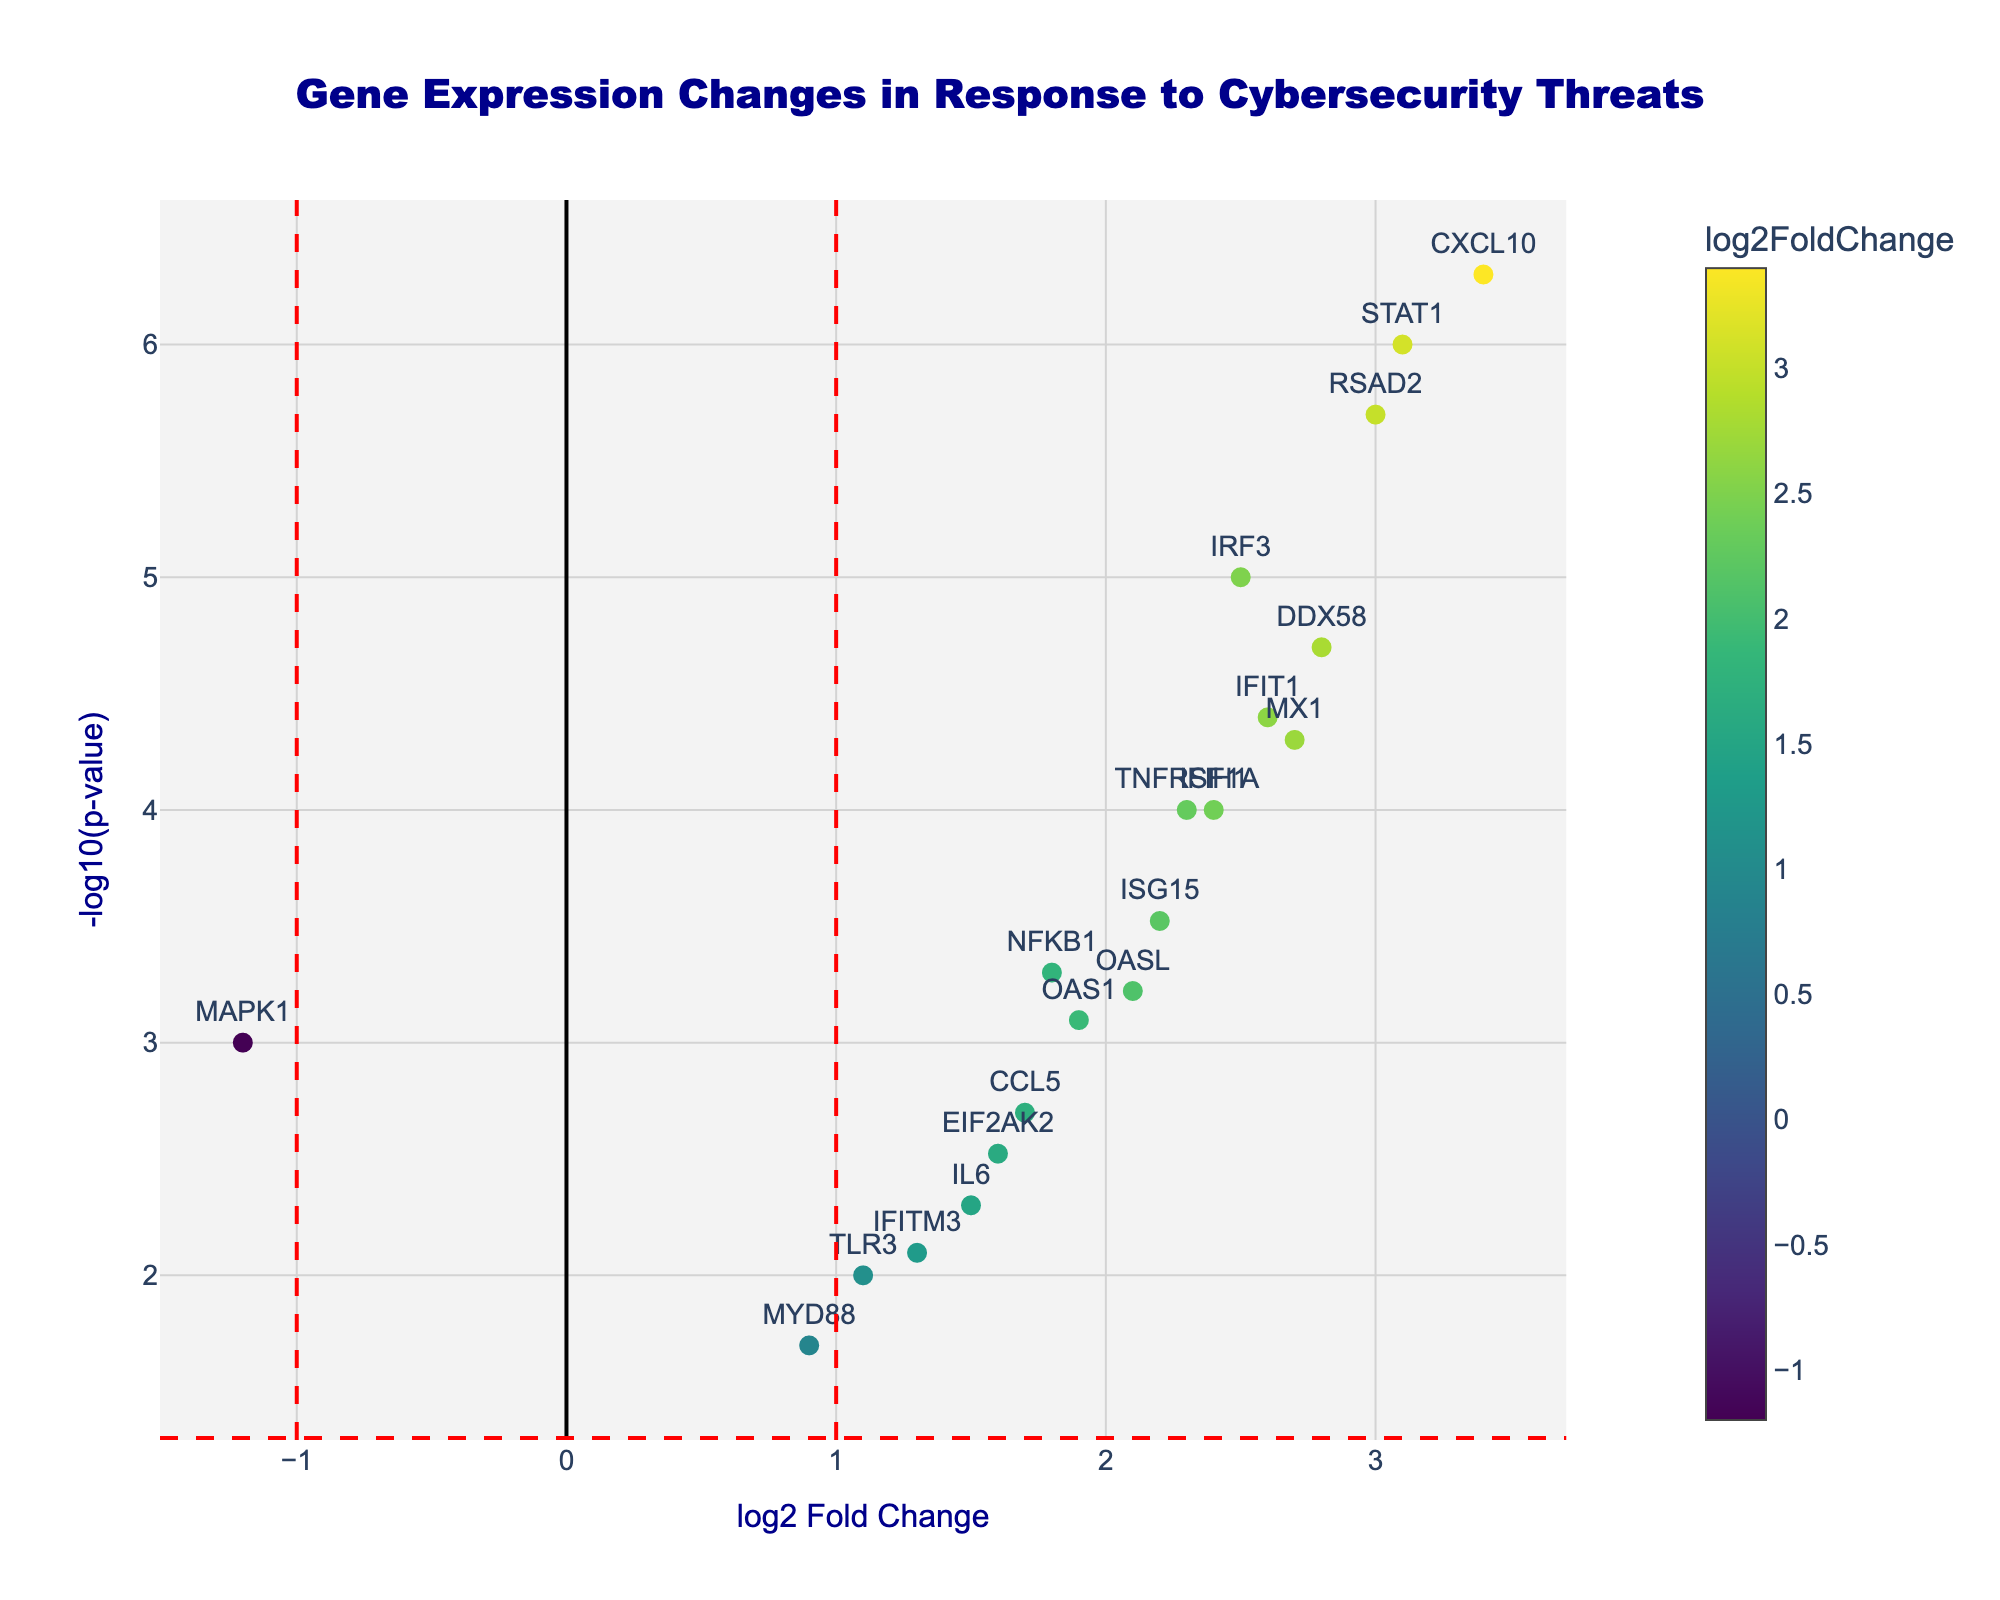What's the title of this plot? The title is clearly displayed at the top of the figure in a large, dark blue font.
Answer: Gene Expression Changes in Response to Cybersecurity Threats What are the axes labels? The x-axis is labeled "log2 Fold Change" and the y-axis is labeled "-log10(p-value)".
Answer: log2 Fold Change and -log10(p-value) How many genes have a log2 Fold Change greater than 2? By examining the x-axis, find the points to the right of the line at x = 2. These points are: TNFRSF1A, IRF3, STAT1, MX1, CXCL10, DDX58, IFIH1, IFIT1, RSAD2, and OASL.
Answer: 10 Which gene has the highest -log10(p-value)? Locate the highest point on the y-axis and identify the corresponding gene text label. The gene at the highest point is CXCL10.
Answer: CXCL10 Are there any genes with a log2 Fold Change less than -1? Check for data points to the left of the line at x = -1. There is only one such point: MAPK1.
Answer: Yes, MAPK1 What's the log2 Fold Change and p-value of the gene CXCL10? The hover text provides detailed info: "CXCL10<br>log2FC: 3.40<br>p-value: 5.00e-07".
Answer: log2FC: 3.40, p-value: 5.00e-07 Which gene has the lowest log2 Fold Change? Examine all the points and find the one farthest to the left on the x-axis. This gene is MYD88.
Answer: MYD88 How many genes are significantly upregulated with a log2 Fold Change greater than 1 and a p-value less than 0.05? Check for points to the right of the line at x = 1 and above the horizontal line at y = -log10(0.05). Count these points: TNFRSF1A, NFKB1, IRF3, STAT1, MX1, OAS1, ISG15, CXCL10, DDX58, IFIH1, IFIT1, RSAD2, CCL5, OASL, EIF2AK2.
Answer: 15 Which genes fall just below the significance threshold (p-value = 0.05) and have a log2 Fold Change greater than 1? Identify genes below the horizontal red line but to the right of x = 1. Specifically, IL6, TLR3, and IFITM3.
Answer: IL6, TLR3, IFITM3 Is there a visible trend indicating higher -log10(p-value) with increasing log2 Fold Change? By observing the scatter plot, you can see most higher points are to the right, indicating a general trend of more significant p-values with greater log2 changes.
Answer: Yes 